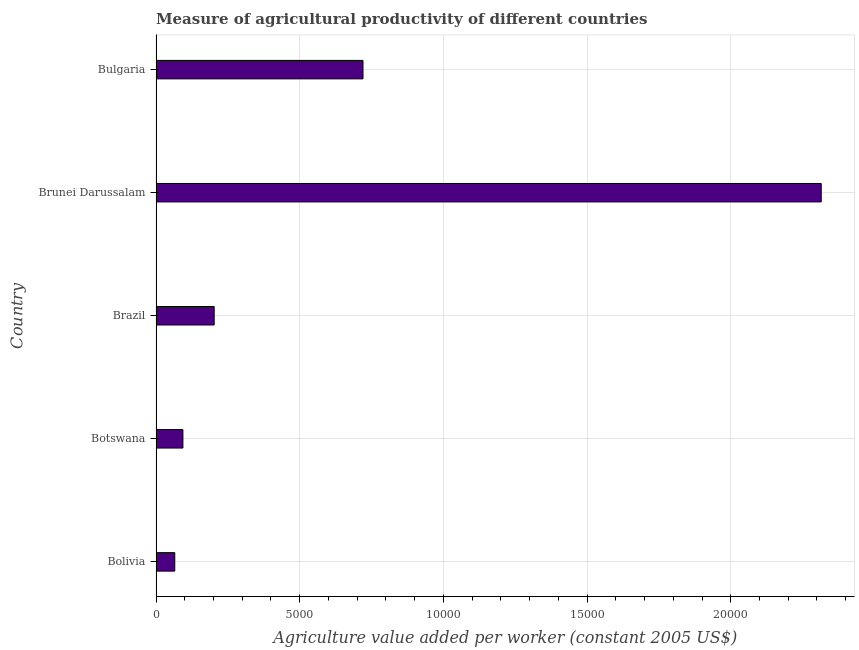What is the title of the graph?
Offer a terse response. Measure of agricultural productivity of different countries. What is the label or title of the X-axis?
Give a very brief answer. Agriculture value added per worker (constant 2005 US$). What is the label or title of the Y-axis?
Ensure brevity in your answer.  Country. What is the agriculture value added per worker in Brunei Darussalam?
Keep it short and to the point. 2.31e+04. Across all countries, what is the maximum agriculture value added per worker?
Keep it short and to the point. 2.31e+04. Across all countries, what is the minimum agriculture value added per worker?
Provide a short and direct response. 652.2. In which country was the agriculture value added per worker maximum?
Offer a very short reply. Brunei Darussalam. In which country was the agriculture value added per worker minimum?
Give a very brief answer. Bolivia. What is the sum of the agriculture value added per worker?
Keep it short and to the point. 3.40e+04. What is the difference between the agriculture value added per worker in Bolivia and Brunei Darussalam?
Offer a very short reply. -2.25e+04. What is the average agriculture value added per worker per country?
Make the answer very short. 6792.44. What is the median agriculture value added per worker?
Ensure brevity in your answer.  2023.58. What is the ratio of the agriculture value added per worker in Bolivia to that in Botswana?
Give a very brief answer. 0.7. Is the difference between the agriculture value added per worker in Brunei Darussalam and Bulgaria greater than the difference between any two countries?
Offer a very short reply. No. What is the difference between the highest and the second highest agriculture value added per worker?
Your response must be concise. 1.59e+04. What is the difference between the highest and the lowest agriculture value added per worker?
Ensure brevity in your answer.  2.25e+04. In how many countries, is the agriculture value added per worker greater than the average agriculture value added per worker taken over all countries?
Provide a short and direct response. 2. Are all the bars in the graph horizontal?
Your answer should be very brief. Yes. What is the difference between two consecutive major ticks on the X-axis?
Ensure brevity in your answer.  5000. Are the values on the major ticks of X-axis written in scientific E-notation?
Offer a terse response. No. What is the Agriculture value added per worker (constant 2005 US$) in Bolivia?
Keep it short and to the point. 652.2. What is the Agriculture value added per worker (constant 2005 US$) of Botswana?
Keep it short and to the point. 935.6. What is the Agriculture value added per worker (constant 2005 US$) in Brazil?
Provide a succinct answer. 2023.58. What is the Agriculture value added per worker (constant 2005 US$) in Brunei Darussalam?
Give a very brief answer. 2.31e+04. What is the Agriculture value added per worker (constant 2005 US$) in Bulgaria?
Keep it short and to the point. 7202.22. What is the difference between the Agriculture value added per worker (constant 2005 US$) in Bolivia and Botswana?
Offer a very short reply. -283.4. What is the difference between the Agriculture value added per worker (constant 2005 US$) in Bolivia and Brazil?
Keep it short and to the point. -1371.39. What is the difference between the Agriculture value added per worker (constant 2005 US$) in Bolivia and Brunei Darussalam?
Offer a very short reply. -2.25e+04. What is the difference between the Agriculture value added per worker (constant 2005 US$) in Bolivia and Bulgaria?
Make the answer very short. -6550.02. What is the difference between the Agriculture value added per worker (constant 2005 US$) in Botswana and Brazil?
Your answer should be compact. -1087.98. What is the difference between the Agriculture value added per worker (constant 2005 US$) in Botswana and Brunei Darussalam?
Give a very brief answer. -2.22e+04. What is the difference between the Agriculture value added per worker (constant 2005 US$) in Botswana and Bulgaria?
Give a very brief answer. -6266.62. What is the difference between the Agriculture value added per worker (constant 2005 US$) in Brazil and Brunei Darussalam?
Your response must be concise. -2.11e+04. What is the difference between the Agriculture value added per worker (constant 2005 US$) in Brazil and Bulgaria?
Give a very brief answer. -5178.64. What is the difference between the Agriculture value added per worker (constant 2005 US$) in Brunei Darussalam and Bulgaria?
Your answer should be very brief. 1.59e+04. What is the ratio of the Agriculture value added per worker (constant 2005 US$) in Bolivia to that in Botswana?
Your answer should be compact. 0.7. What is the ratio of the Agriculture value added per worker (constant 2005 US$) in Bolivia to that in Brazil?
Your answer should be very brief. 0.32. What is the ratio of the Agriculture value added per worker (constant 2005 US$) in Bolivia to that in Brunei Darussalam?
Keep it short and to the point. 0.03. What is the ratio of the Agriculture value added per worker (constant 2005 US$) in Bolivia to that in Bulgaria?
Your response must be concise. 0.09. What is the ratio of the Agriculture value added per worker (constant 2005 US$) in Botswana to that in Brazil?
Your answer should be very brief. 0.46. What is the ratio of the Agriculture value added per worker (constant 2005 US$) in Botswana to that in Bulgaria?
Make the answer very short. 0.13. What is the ratio of the Agriculture value added per worker (constant 2005 US$) in Brazil to that in Brunei Darussalam?
Provide a succinct answer. 0.09. What is the ratio of the Agriculture value added per worker (constant 2005 US$) in Brazil to that in Bulgaria?
Ensure brevity in your answer.  0.28. What is the ratio of the Agriculture value added per worker (constant 2005 US$) in Brunei Darussalam to that in Bulgaria?
Your response must be concise. 3.21. 